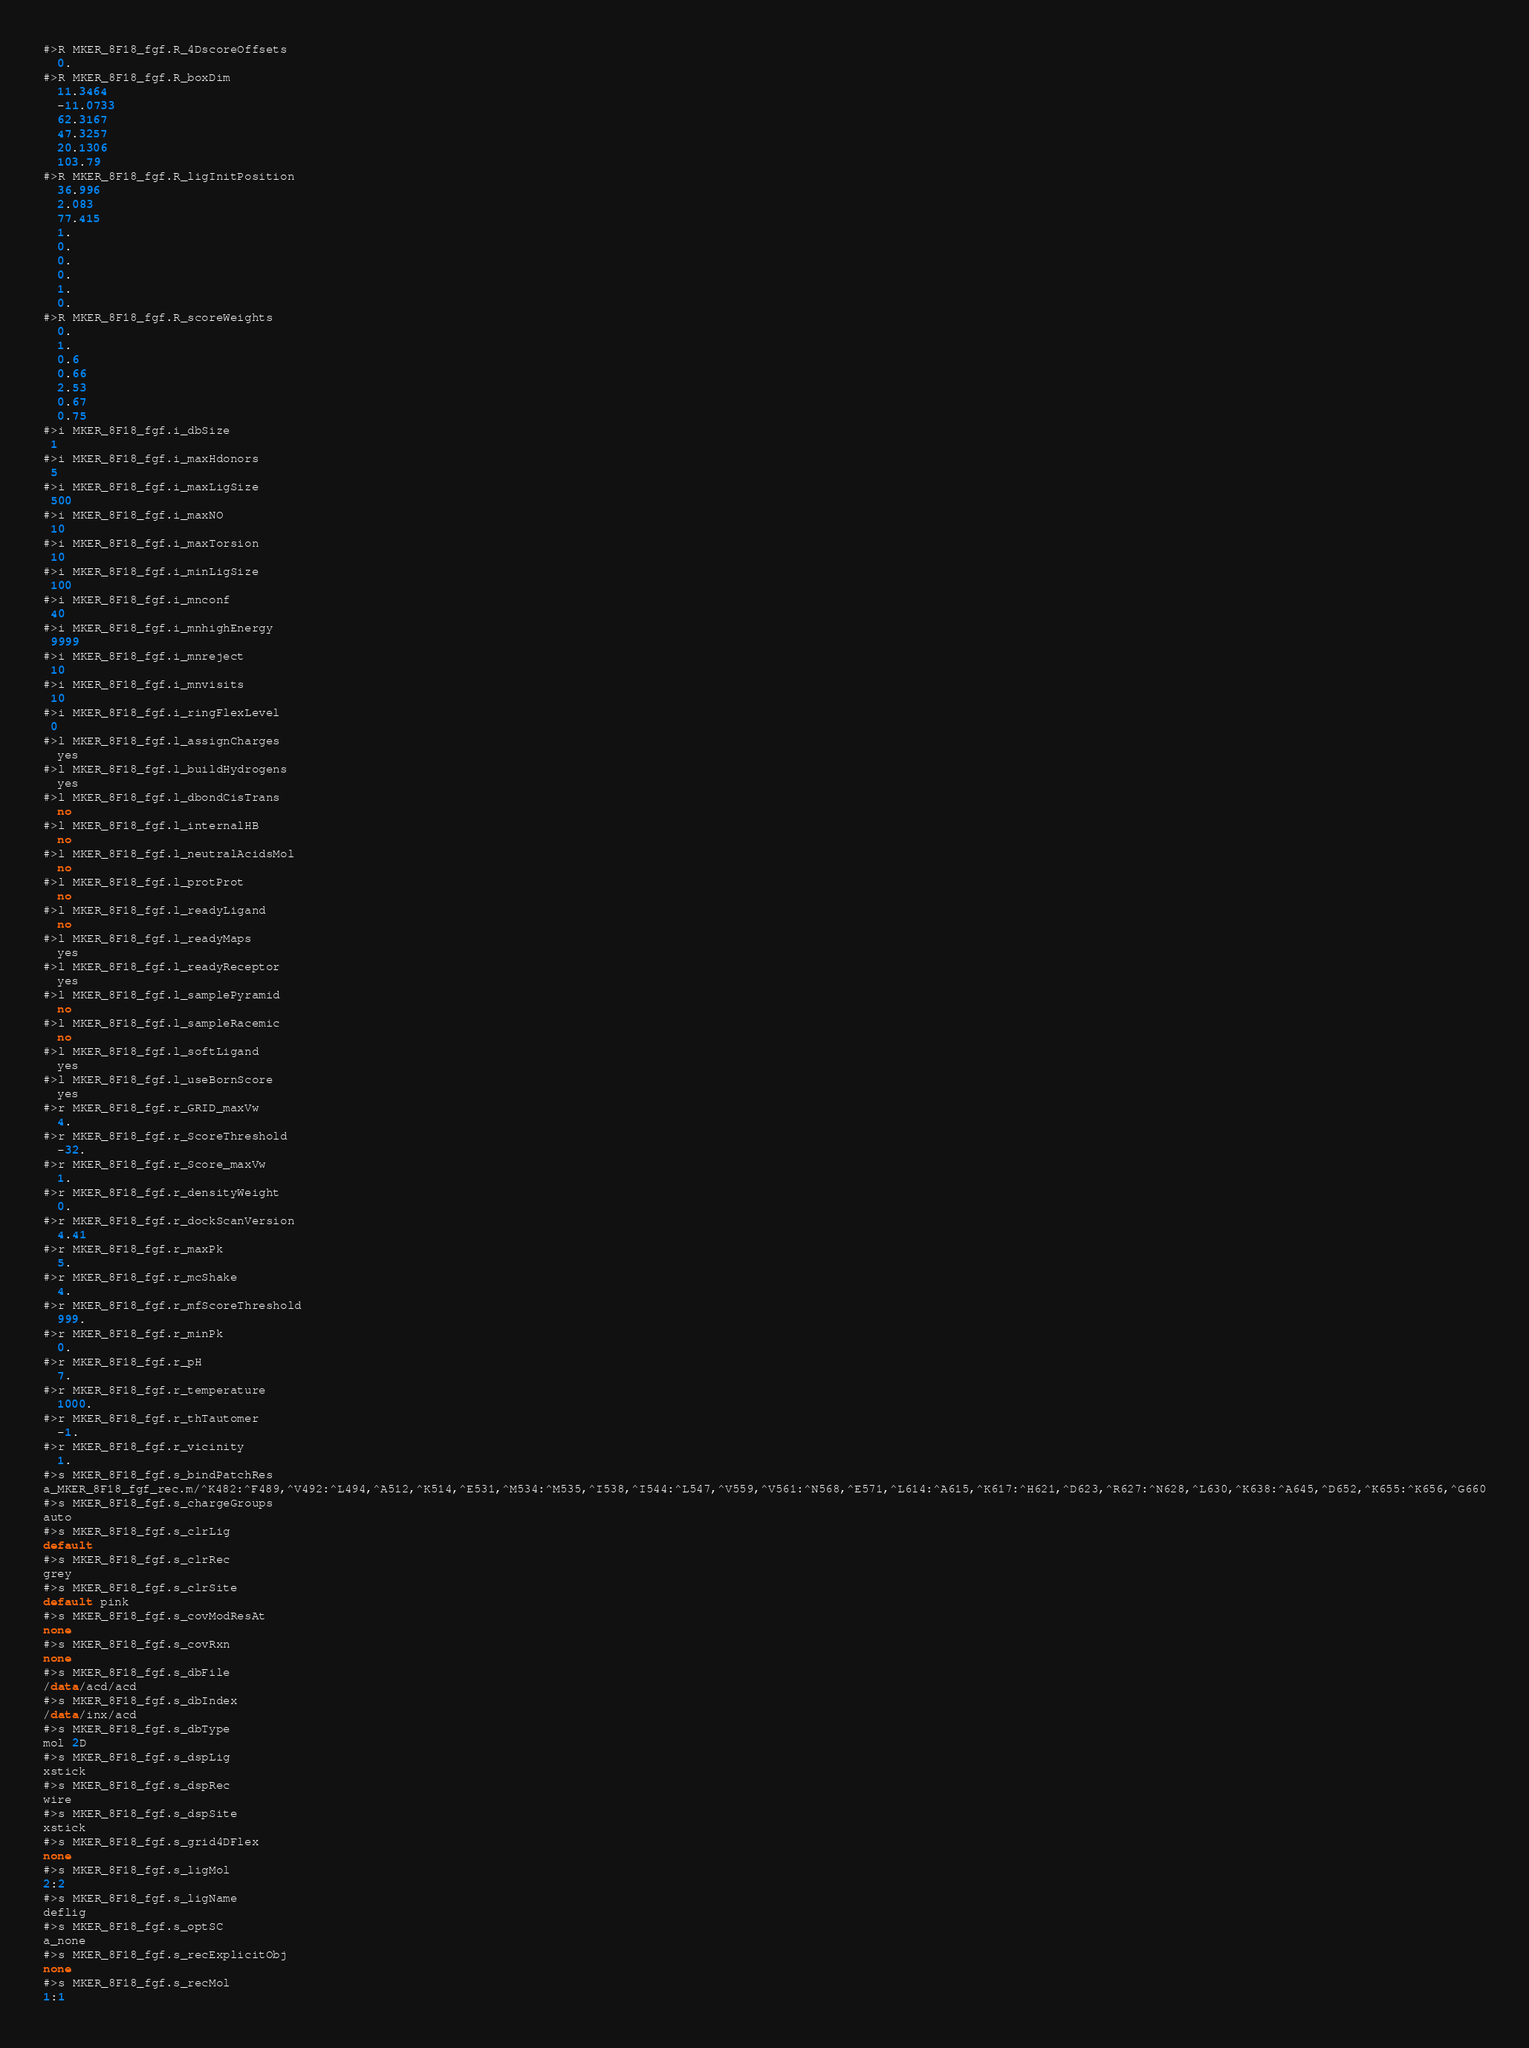Convert code to text. <code><loc_0><loc_0><loc_500><loc_500><_SQL_>#>R MKER_8F18_fgf.R_4DscoreOffsets
  0.
#>R MKER_8F18_fgf.R_boxDim
  11.3464
  -11.0733
  62.3167
  47.3257
  20.1306
  103.79
#>R MKER_8F18_fgf.R_ligInitPosition
  36.996
  2.083
  77.415
  1.
  0.
  0.
  0.
  1.
  0.
#>R MKER_8F18_fgf.R_scoreWeights
  0.
  1.
  0.6
  0.66
  2.53
  0.67
  0.75
#>i MKER_8F18_fgf.i_dbSize
 1
#>i MKER_8F18_fgf.i_maxHdonors
 5
#>i MKER_8F18_fgf.i_maxLigSize
 500
#>i MKER_8F18_fgf.i_maxNO
 10
#>i MKER_8F18_fgf.i_maxTorsion
 10
#>i MKER_8F18_fgf.i_minLigSize
 100
#>i MKER_8F18_fgf.i_mnconf
 40
#>i MKER_8F18_fgf.i_mnhighEnergy
 9999
#>i MKER_8F18_fgf.i_mnreject
 10
#>i MKER_8F18_fgf.i_mnvisits
 10
#>i MKER_8F18_fgf.i_ringFlexLevel
 0
#>l MKER_8F18_fgf.l_assignCharges
  yes
#>l MKER_8F18_fgf.l_buildHydrogens
  yes
#>l MKER_8F18_fgf.l_dbondCisTrans
  no
#>l MKER_8F18_fgf.l_internalHB
  no
#>l MKER_8F18_fgf.l_neutralAcidsMol
  no
#>l MKER_8F18_fgf.l_protProt
  no
#>l MKER_8F18_fgf.l_readyLigand
  no
#>l MKER_8F18_fgf.l_readyMaps
  yes
#>l MKER_8F18_fgf.l_readyReceptor
  yes
#>l MKER_8F18_fgf.l_samplePyramid
  no
#>l MKER_8F18_fgf.l_sampleRacemic
  no
#>l MKER_8F18_fgf.l_softLigand
  yes
#>l MKER_8F18_fgf.l_useBornScore
  yes
#>r MKER_8F18_fgf.r_GRID_maxVw
  4.
#>r MKER_8F18_fgf.r_ScoreThreshold
  -32.
#>r MKER_8F18_fgf.r_Score_maxVw
  1.
#>r MKER_8F18_fgf.r_densityWeight
  0.
#>r MKER_8F18_fgf.r_dockScanVersion
  4.41
#>r MKER_8F18_fgf.r_maxPk
  5.
#>r MKER_8F18_fgf.r_mcShake
  4.
#>r MKER_8F18_fgf.r_mfScoreThreshold
  999.
#>r MKER_8F18_fgf.r_minPk
  0.
#>r MKER_8F18_fgf.r_pH
  7.
#>r MKER_8F18_fgf.r_temperature
  1000.
#>r MKER_8F18_fgf.r_thTautomer
  -1.
#>r MKER_8F18_fgf.r_vicinity
  1.
#>s MKER_8F18_fgf.s_bindPatchRes
a_MKER_8F18_fgf_rec.m/^K482:^F489,^V492:^L494,^A512,^K514,^E531,^M534:^M535,^I538,^I544:^L547,^V559,^V561:^N568,^E571,^L614:^A615,^K617:^H621,^D623,^R627:^N628,^L630,^K638:^A645,^D652,^K655:^K656,^G660
#>s MKER_8F18_fgf.s_chargeGroups
auto
#>s MKER_8F18_fgf.s_clrLig
default
#>s MKER_8F18_fgf.s_clrRec
grey
#>s MKER_8F18_fgf.s_clrSite
default pink
#>s MKER_8F18_fgf.s_covModResAt
none
#>s MKER_8F18_fgf.s_covRxn
none
#>s MKER_8F18_fgf.s_dbFile
/data/acd/acd
#>s MKER_8F18_fgf.s_dbIndex
/data/inx/acd
#>s MKER_8F18_fgf.s_dbType
mol 2D
#>s MKER_8F18_fgf.s_dspLig
xstick
#>s MKER_8F18_fgf.s_dspRec
wire
#>s MKER_8F18_fgf.s_dspSite
xstick
#>s MKER_8F18_fgf.s_grid4DFlex
none
#>s MKER_8F18_fgf.s_ligMol
2:2
#>s MKER_8F18_fgf.s_ligName
deflig
#>s MKER_8F18_fgf.s_optSC
a_none
#>s MKER_8F18_fgf.s_recExplicitObj
none
#>s MKER_8F18_fgf.s_recMol
1:1</code> 